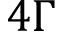Convert formula to latex. <formula><loc_0><loc_0><loc_500><loc_500>4 \Gamma</formula> 